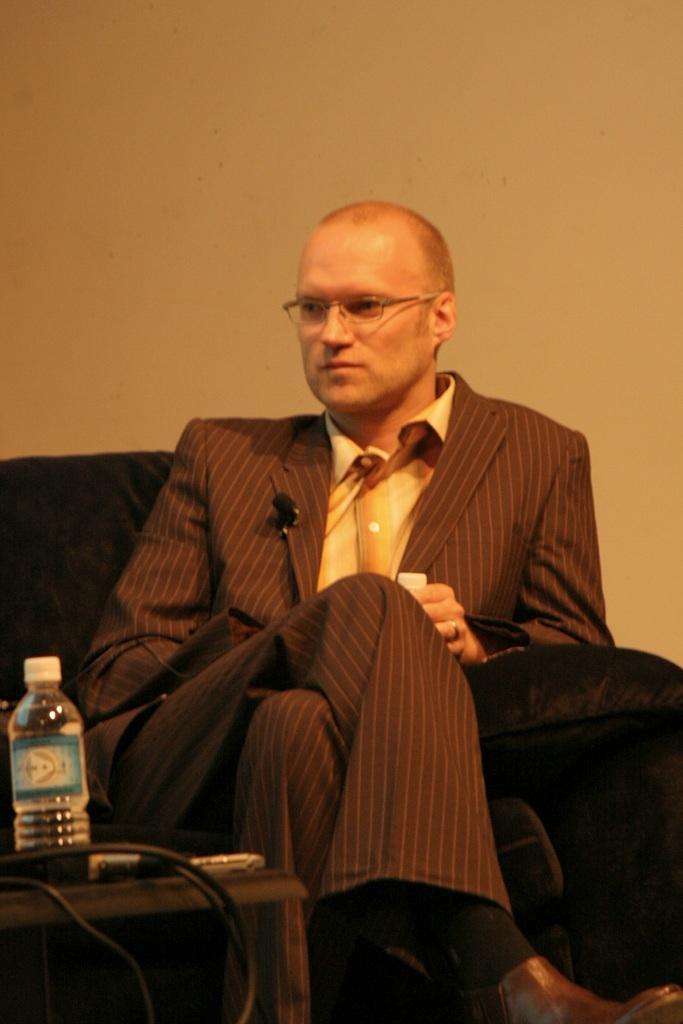Can you describe this image briefly? In this image i can see a person sitting on the chair and wearing a gray color coat and he wearing a spectacles,in front of him there is a table and there is a bottle kept on the table an a cable wire kept on that. 